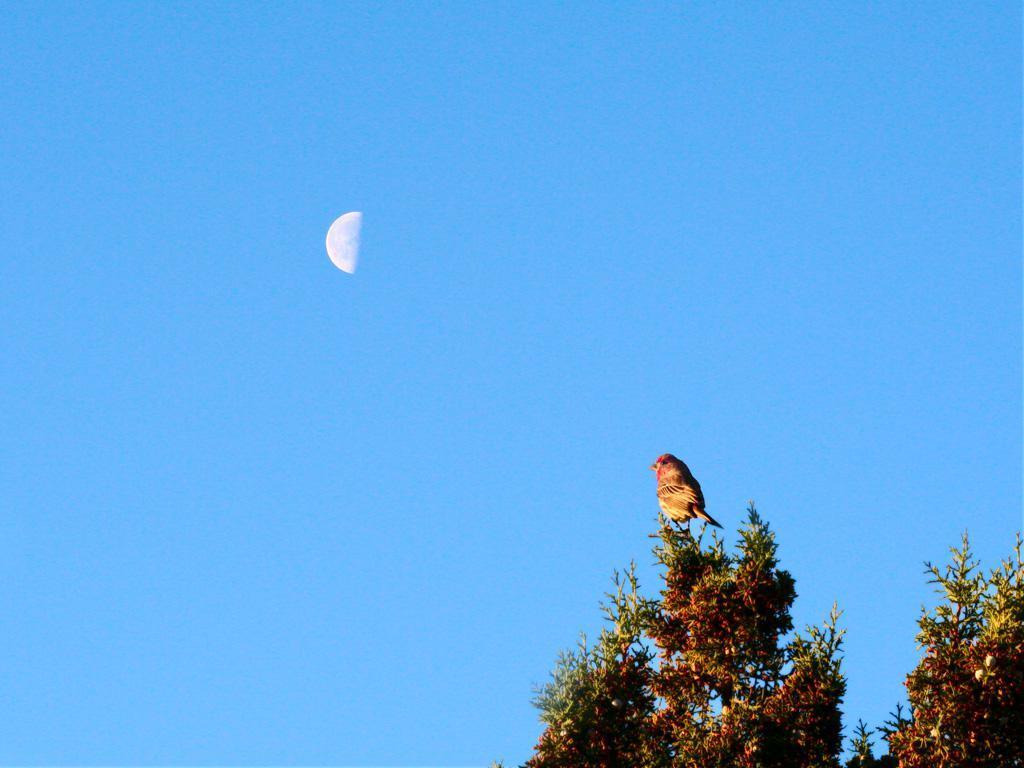Describe this image in one or two sentences. In this picture I can see there is a tree on right side and there is a bird sitting on the top of the tree. There is half moon is visible in the sky and the sky is clear. 